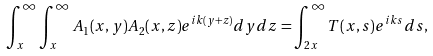Convert formula to latex. <formula><loc_0><loc_0><loc_500><loc_500>\int ^ { \infty } _ { x } \int ^ { \infty } _ { x } A _ { 1 } ( x , y ) A _ { 2 } ( x , z ) e ^ { i k ( y + z ) } d y d z = \int ^ { \infty } _ { 2 x } T ( x , s ) e ^ { i k s } d s ,</formula> 